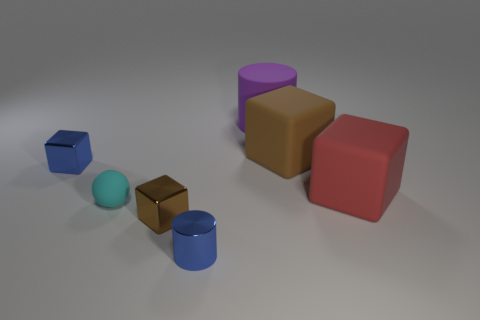What could be the purpose of arranging these shapes in this specific layout? The arrangement of these shapes might be designed to illustrate concepts in geometry, such as comparing sizes, distances, and spatial relationships, or it could serve as a visual aid for 3D modeling and lighting practice. 